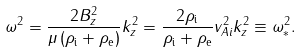<formula> <loc_0><loc_0><loc_500><loc_500>\omega ^ { 2 } = \frac { 2 B _ { z } ^ { 2 } } { \mu \, ( \rho _ { \mathrm i } + \rho _ { \mathrm e } ) } k _ { z } ^ { 2 } = \frac { 2 \rho _ { \mathrm i } } { \rho _ { \mathrm i } + \rho _ { \mathrm e } } v _ { A i } ^ { 2 } k _ { z } ^ { 2 } \equiv \omega _ { * } ^ { 2 } .</formula> 